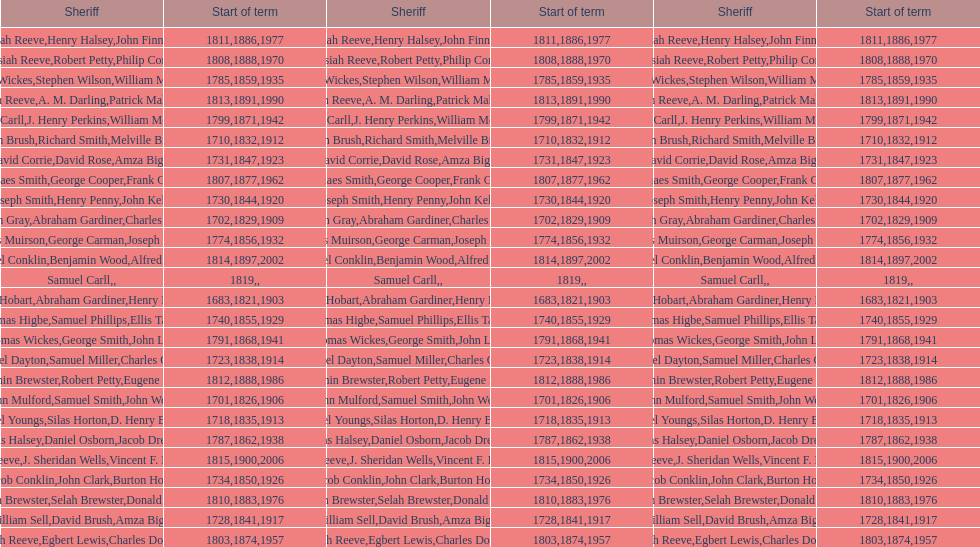When did benjamin brewster serve his second term? 1812. 